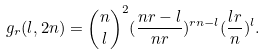Convert formula to latex. <formula><loc_0><loc_0><loc_500><loc_500>g _ { r } ( l , 2 n ) = { n \choose l } ^ { 2 } ( \frac { n r - l } { n r } ) ^ { r n - l } ( \frac { l r } { n } ) ^ { l } .</formula> 